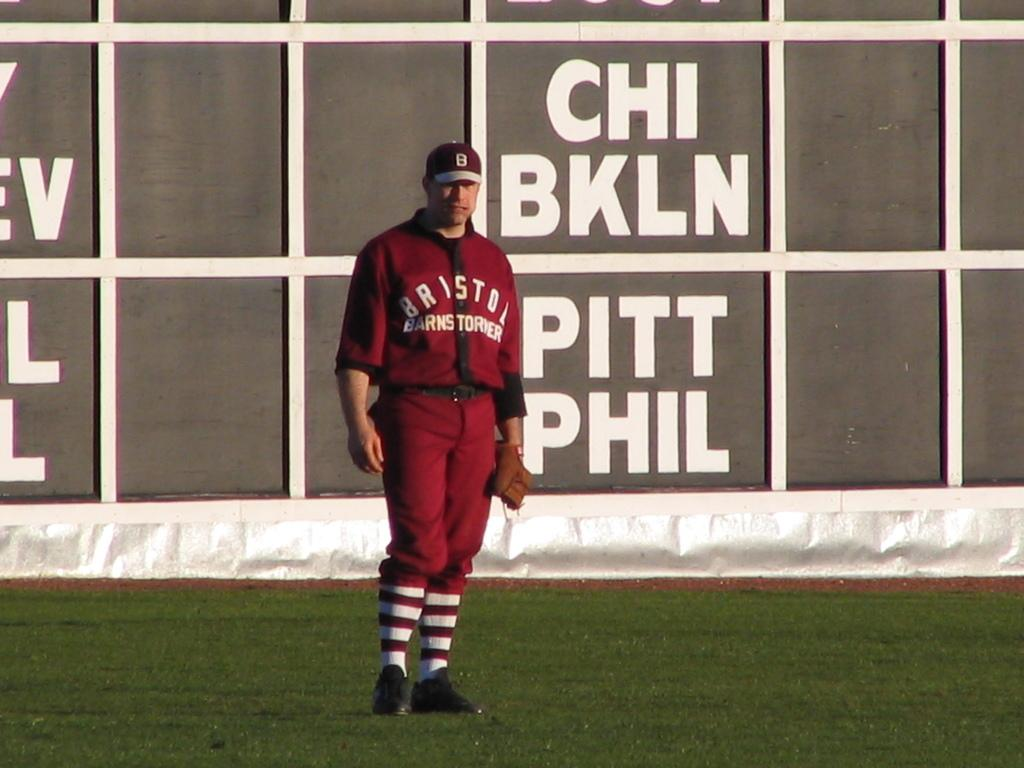<image>
Share a concise interpretation of the image provided. Baseball player on the field wearing a sweater that says Bristol. 